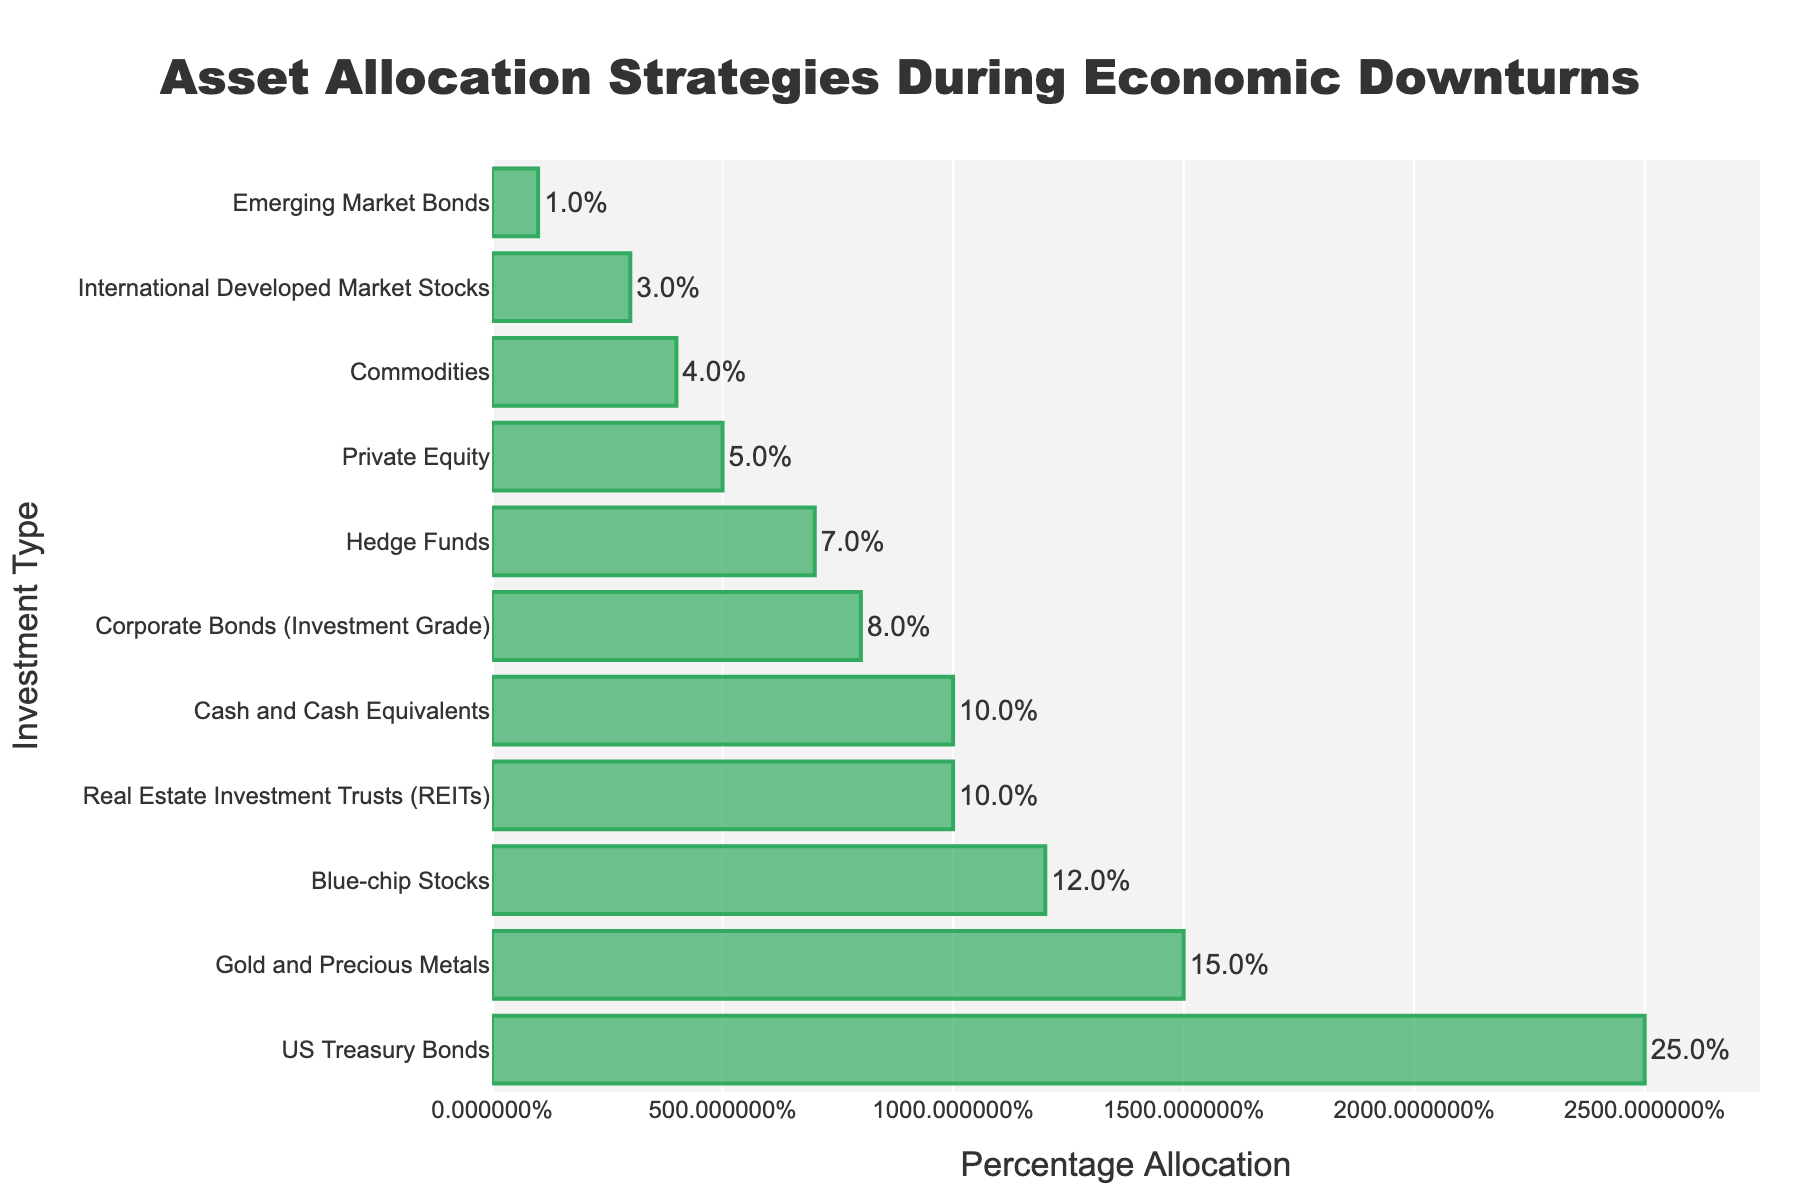What is the investment type with the highest percentage allocation? The bar chart shows the percentage allocation for each investment type, and the bar with the highest allocation is the longest.
Answer: US Treasury Bonds Which investment types have an allocation greater than 10%? By examining the lengths of the bars, we identify the bars that extend beyond the 10% mark.
Answer: US Treasury Bonds, Gold and Precious Metals, Blue-chip Stocks, Real Estate Investment Trusts (REITs), Cash and Cash Equivalents How much more is allocated to US Treasury Bonds compared to Gold and Precious Metals? Subtract the allocation percentage of Gold and Precious Metals (15%) from that of US Treasury Bonds (25%).
Answer: 10% What is the combined percentage allocation for Blue-chip Stocks, REITs, and Cash and Cash Equivalents? Add the allocation percentages of Blue-chip Stocks (12%), REITs (10%), and Cash and Cash Equivalents (10%).
Answer: 32% Which investment type has the lowest allocation, and what is its percentage? Find the shortest bar on the chart and read its value.
Answer: Emerging Market Bonds, 1% Are Hedge Funds or Private Equity allocated a higher percentage? Compare the lengths of the bars representing Hedge Funds and Private Equity.
Answer: Hedge Funds What is the average percentage allocation of Corporate Bonds (Investment Grade), Hedge Funds, and Commodities? Sum the allocation percentages of Corporate Bonds (8%), Hedge Funds (7%), and Commodities (4%) and divide by 3. (8 + 7 + 4) / 3 = 6.33 (approximately).
Answer: 6.3% How does the allocation for REITs compare to that for Corporate Bonds? Subtract the allocation percentage of Corporate Bonds (8%) from that of REITs (10%).
Answer: 2% What percentage of the total assets is allocated to Commodities and International Developed Market Stocks combined? Add the allocation percentages of Commodities (4%) and International Developed Market Stocks (3%).
Answer: 7% 